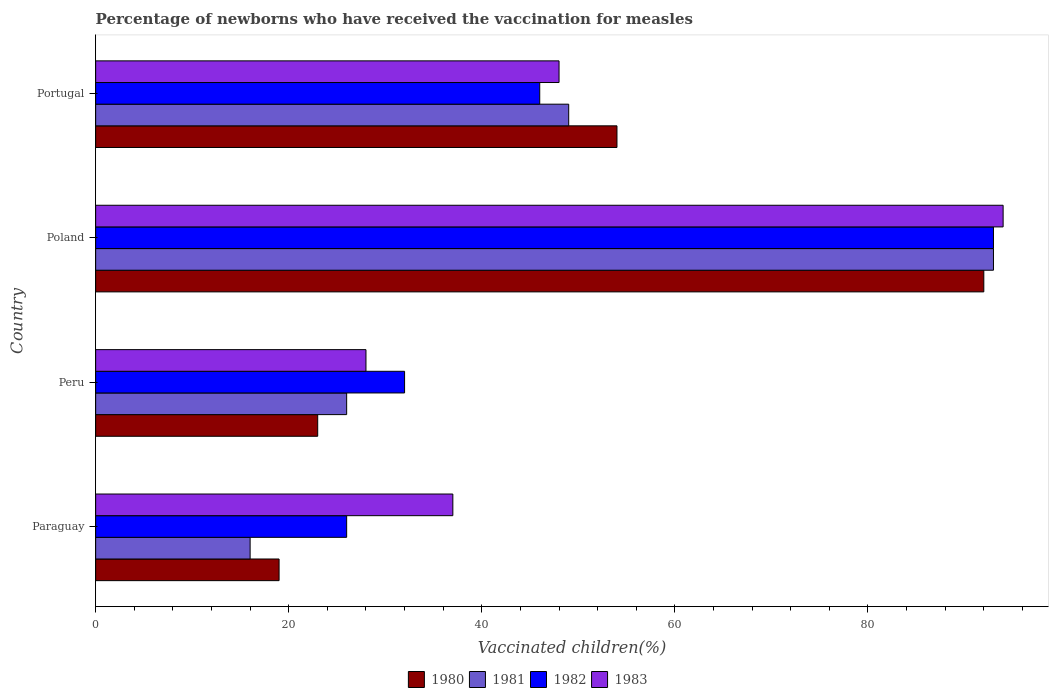How many different coloured bars are there?
Your answer should be compact. 4. Are the number of bars per tick equal to the number of legend labels?
Your answer should be very brief. Yes. How many bars are there on the 4th tick from the bottom?
Offer a terse response. 4. What is the label of the 1st group of bars from the top?
Give a very brief answer. Portugal. In how many cases, is the number of bars for a given country not equal to the number of legend labels?
Your answer should be compact. 0. What is the percentage of vaccinated children in 1980 in Portugal?
Your response must be concise. 54. Across all countries, what is the maximum percentage of vaccinated children in 1982?
Ensure brevity in your answer.  93. Across all countries, what is the minimum percentage of vaccinated children in 1982?
Provide a succinct answer. 26. In which country was the percentage of vaccinated children in 1980 minimum?
Give a very brief answer. Paraguay. What is the total percentage of vaccinated children in 1980 in the graph?
Provide a short and direct response. 188. What is the difference between the percentage of vaccinated children in 1983 in Peru and that in Poland?
Offer a terse response. -66. What is the difference between the percentage of vaccinated children in 1983 in Poland and the percentage of vaccinated children in 1982 in Paraguay?
Ensure brevity in your answer.  68. What is the average percentage of vaccinated children in 1982 per country?
Your answer should be very brief. 49.25. What is the difference between the percentage of vaccinated children in 1983 and percentage of vaccinated children in 1981 in Paraguay?
Keep it short and to the point. 21. In how many countries, is the percentage of vaccinated children in 1982 greater than 36 %?
Give a very brief answer. 2. What is the ratio of the percentage of vaccinated children in 1983 in Poland to that in Portugal?
Keep it short and to the point. 1.96. Is the percentage of vaccinated children in 1983 in Paraguay less than that in Portugal?
Make the answer very short. Yes. Is the difference between the percentage of vaccinated children in 1983 in Peru and Portugal greater than the difference between the percentage of vaccinated children in 1981 in Peru and Portugal?
Give a very brief answer. Yes. What is the difference between the highest and the lowest percentage of vaccinated children in 1980?
Your response must be concise. 73. Is the sum of the percentage of vaccinated children in 1980 in Poland and Portugal greater than the maximum percentage of vaccinated children in 1981 across all countries?
Give a very brief answer. Yes. Is it the case that in every country, the sum of the percentage of vaccinated children in 1983 and percentage of vaccinated children in 1980 is greater than the sum of percentage of vaccinated children in 1982 and percentage of vaccinated children in 1981?
Your answer should be compact. No. What is the difference between two consecutive major ticks on the X-axis?
Your answer should be compact. 20. Are the values on the major ticks of X-axis written in scientific E-notation?
Keep it short and to the point. No. How many legend labels are there?
Provide a short and direct response. 4. How are the legend labels stacked?
Keep it short and to the point. Horizontal. What is the title of the graph?
Offer a very short reply. Percentage of newborns who have received the vaccination for measles. What is the label or title of the X-axis?
Your response must be concise. Vaccinated children(%). What is the label or title of the Y-axis?
Give a very brief answer. Country. What is the Vaccinated children(%) of 1980 in Paraguay?
Provide a short and direct response. 19. What is the Vaccinated children(%) of 1981 in Paraguay?
Give a very brief answer. 16. What is the Vaccinated children(%) of 1982 in Paraguay?
Give a very brief answer. 26. What is the Vaccinated children(%) of 1983 in Paraguay?
Your response must be concise. 37. What is the Vaccinated children(%) of 1980 in Peru?
Make the answer very short. 23. What is the Vaccinated children(%) in 1981 in Peru?
Your answer should be compact. 26. What is the Vaccinated children(%) in 1982 in Peru?
Keep it short and to the point. 32. What is the Vaccinated children(%) of 1983 in Peru?
Offer a very short reply. 28. What is the Vaccinated children(%) in 1980 in Poland?
Keep it short and to the point. 92. What is the Vaccinated children(%) in 1981 in Poland?
Your answer should be very brief. 93. What is the Vaccinated children(%) of 1982 in Poland?
Offer a very short reply. 93. What is the Vaccinated children(%) of 1983 in Poland?
Offer a very short reply. 94. What is the Vaccinated children(%) in 1980 in Portugal?
Ensure brevity in your answer.  54. What is the Vaccinated children(%) in 1981 in Portugal?
Your answer should be very brief. 49. What is the Vaccinated children(%) in 1983 in Portugal?
Offer a terse response. 48. Across all countries, what is the maximum Vaccinated children(%) in 1980?
Give a very brief answer. 92. Across all countries, what is the maximum Vaccinated children(%) of 1981?
Provide a short and direct response. 93. Across all countries, what is the maximum Vaccinated children(%) of 1982?
Keep it short and to the point. 93. Across all countries, what is the maximum Vaccinated children(%) of 1983?
Your answer should be very brief. 94. What is the total Vaccinated children(%) in 1980 in the graph?
Give a very brief answer. 188. What is the total Vaccinated children(%) of 1981 in the graph?
Provide a succinct answer. 184. What is the total Vaccinated children(%) of 1982 in the graph?
Provide a succinct answer. 197. What is the total Vaccinated children(%) of 1983 in the graph?
Offer a terse response. 207. What is the difference between the Vaccinated children(%) of 1980 in Paraguay and that in Poland?
Your answer should be compact. -73. What is the difference between the Vaccinated children(%) in 1981 in Paraguay and that in Poland?
Give a very brief answer. -77. What is the difference between the Vaccinated children(%) in 1982 in Paraguay and that in Poland?
Ensure brevity in your answer.  -67. What is the difference between the Vaccinated children(%) in 1983 in Paraguay and that in Poland?
Offer a very short reply. -57. What is the difference between the Vaccinated children(%) of 1980 in Paraguay and that in Portugal?
Ensure brevity in your answer.  -35. What is the difference between the Vaccinated children(%) of 1981 in Paraguay and that in Portugal?
Make the answer very short. -33. What is the difference between the Vaccinated children(%) of 1982 in Paraguay and that in Portugal?
Give a very brief answer. -20. What is the difference between the Vaccinated children(%) in 1983 in Paraguay and that in Portugal?
Offer a very short reply. -11. What is the difference between the Vaccinated children(%) of 1980 in Peru and that in Poland?
Make the answer very short. -69. What is the difference between the Vaccinated children(%) in 1981 in Peru and that in Poland?
Keep it short and to the point. -67. What is the difference between the Vaccinated children(%) in 1982 in Peru and that in Poland?
Offer a very short reply. -61. What is the difference between the Vaccinated children(%) of 1983 in Peru and that in Poland?
Give a very brief answer. -66. What is the difference between the Vaccinated children(%) of 1980 in Peru and that in Portugal?
Make the answer very short. -31. What is the difference between the Vaccinated children(%) of 1981 in Peru and that in Portugal?
Your answer should be compact. -23. What is the difference between the Vaccinated children(%) of 1982 in Peru and that in Portugal?
Give a very brief answer. -14. What is the difference between the Vaccinated children(%) in 1983 in Peru and that in Portugal?
Keep it short and to the point. -20. What is the difference between the Vaccinated children(%) of 1980 in Poland and that in Portugal?
Ensure brevity in your answer.  38. What is the difference between the Vaccinated children(%) in 1981 in Poland and that in Portugal?
Provide a short and direct response. 44. What is the difference between the Vaccinated children(%) in 1980 in Paraguay and the Vaccinated children(%) in 1982 in Peru?
Give a very brief answer. -13. What is the difference between the Vaccinated children(%) of 1980 in Paraguay and the Vaccinated children(%) of 1981 in Poland?
Offer a very short reply. -74. What is the difference between the Vaccinated children(%) of 1980 in Paraguay and the Vaccinated children(%) of 1982 in Poland?
Your answer should be compact. -74. What is the difference between the Vaccinated children(%) in 1980 in Paraguay and the Vaccinated children(%) in 1983 in Poland?
Provide a short and direct response. -75. What is the difference between the Vaccinated children(%) of 1981 in Paraguay and the Vaccinated children(%) of 1982 in Poland?
Ensure brevity in your answer.  -77. What is the difference between the Vaccinated children(%) in 1981 in Paraguay and the Vaccinated children(%) in 1983 in Poland?
Offer a very short reply. -78. What is the difference between the Vaccinated children(%) in 1982 in Paraguay and the Vaccinated children(%) in 1983 in Poland?
Your answer should be very brief. -68. What is the difference between the Vaccinated children(%) of 1980 in Paraguay and the Vaccinated children(%) of 1981 in Portugal?
Give a very brief answer. -30. What is the difference between the Vaccinated children(%) in 1980 in Paraguay and the Vaccinated children(%) in 1982 in Portugal?
Your answer should be compact. -27. What is the difference between the Vaccinated children(%) of 1981 in Paraguay and the Vaccinated children(%) of 1982 in Portugal?
Your response must be concise. -30. What is the difference between the Vaccinated children(%) in 1981 in Paraguay and the Vaccinated children(%) in 1983 in Portugal?
Make the answer very short. -32. What is the difference between the Vaccinated children(%) in 1980 in Peru and the Vaccinated children(%) in 1981 in Poland?
Offer a terse response. -70. What is the difference between the Vaccinated children(%) of 1980 in Peru and the Vaccinated children(%) of 1982 in Poland?
Make the answer very short. -70. What is the difference between the Vaccinated children(%) in 1980 in Peru and the Vaccinated children(%) in 1983 in Poland?
Your response must be concise. -71. What is the difference between the Vaccinated children(%) in 1981 in Peru and the Vaccinated children(%) in 1982 in Poland?
Give a very brief answer. -67. What is the difference between the Vaccinated children(%) in 1981 in Peru and the Vaccinated children(%) in 1983 in Poland?
Offer a very short reply. -68. What is the difference between the Vaccinated children(%) of 1982 in Peru and the Vaccinated children(%) of 1983 in Poland?
Your answer should be very brief. -62. What is the difference between the Vaccinated children(%) in 1980 in Peru and the Vaccinated children(%) in 1983 in Portugal?
Offer a very short reply. -25. What is the difference between the Vaccinated children(%) of 1981 in Peru and the Vaccinated children(%) of 1983 in Portugal?
Ensure brevity in your answer.  -22. What is the difference between the Vaccinated children(%) in 1980 in Poland and the Vaccinated children(%) in 1983 in Portugal?
Make the answer very short. 44. What is the difference between the Vaccinated children(%) in 1982 in Poland and the Vaccinated children(%) in 1983 in Portugal?
Provide a short and direct response. 45. What is the average Vaccinated children(%) of 1980 per country?
Offer a terse response. 47. What is the average Vaccinated children(%) of 1981 per country?
Give a very brief answer. 46. What is the average Vaccinated children(%) of 1982 per country?
Provide a short and direct response. 49.25. What is the average Vaccinated children(%) in 1983 per country?
Keep it short and to the point. 51.75. What is the difference between the Vaccinated children(%) in 1981 and Vaccinated children(%) in 1983 in Paraguay?
Make the answer very short. -21. What is the difference between the Vaccinated children(%) in 1980 and Vaccinated children(%) in 1983 in Peru?
Offer a very short reply. -5. What is the difference between the Vaccinated children(%) of 1980 and Vaccinated children(%) of 1983 in Poland?
Provide a succinct answer. -2. What is the difference between the Vaccinated children(%) in 1981 and Vaccinated children(%) in 1982 in Poland?
Keep it short and to the point. 0. What is the difference between the Vaccinated children(%) of 1981 and Vaccinated children(%) of 1983 in Poland?
Make the answer very short. -1. What is the difference between the Vaccinated children(%) of 1980 and Vaccinated children(%) of 1981 in Portugal?
Make the answer very short. 5. What is the difference between the Vaccinated children(%) in 1980 and Vaccinated children(%) in 1983 in Portugal?
Offer a very short reply. 6. What is the ratio of the Vaccinated children(%) in 1980 in Paraguay to that in Peru?
Give a very brief answer. 0.83. What is the ratio of the Vaccinated children(%) of 1981 in Paraguay to that in Peru?
Ensure brevity in your answer.  0.62. What is the ratio of the Vaccinated children(%) of 1982 in Paraguay to that in Peru?
Offer a terse response. 0.81. What is the ratio of the Vaccinated children(%) of 1983 in Paraguay to that in Peru?
Give a very brief answer. 1.32. What is the ratio of the Vaccinated children(%) in 1980 in Paraguay to that in Poland?
Ensure brevity in your answer.  0.21. What is the ratio of the Vaccinated children(%) of 1981 in Paraguay to that in Poland?
Ensure brevity in your answer.  0.17. What is the ratio of the Vaccinated children(%) in 1982 in Paraguay to that in Poland?
Offer a terse response. 0.28. What is the ratio of the Vaccinated children(%) of 1983 in Paraguay to that in Poland?
Your answer should be very brief. 0.39. What is the ratio of the Vaccinated children(%) of 1980 in Paraguay to that in Portugal?
Your answer should be very brief. 0.35. What is the ratio of the Vaccinated children(%) in 1981 in Paraguay to that in Portugal?
Provide a short and direct response. 0.33. What is the ratio of the Vaccinated children(%) in 1982 in Paraguay to that in Portugal?
Your answer should be compact. 0.57. What is the ratio of the Vaccinated children(%) of 1983 in Paraguay to that in Portugal?
Provide a short and direct response. 0.77. What is the ratio of the Vaccinated children(%) of 1980 in Peru to that in Poland?
Provide a short and direct response. 0.25. What is the ratio of the Vaccinated children(%) in 1981 in Peru to that in Poland?
Offer a terse response. 0.28. What is the ratio of the Vaccinated children(%) of 1982 in Peru to that in Poland?
Your answer should be very brief. 0.34. What is the ratio of the Vaccinated children(%) of 1983 in Peru to that in Poland?
Provide a short and direct response. 0.3. What is the ratio of the Vaccinated children(%) of 1980 in Peru to that in Portugal?
Your answer should be very brief. 0.43. What is the ratio of the Vaccinated children(%) in 1981 in Peru to that in Portugal?
Ensure brevity in your answer.  0.53. What is the ratio of the Vaccinated children(%) in 1982 in Peru to that in Portugal?
Keep it short and to the point. 0.7. What is the ratio of the Vaccinated children(%) of 1983 in Peru to that in Portugal?
Your answer should be compact. 0.58. What is the ratio of the Vaccinated children(%) of 1980 in Poland to that in Portugal?
Provide a succinct answer. 1.7. What is the ratio of the Vaccinated children(%) of 1981 in Poland to that in Portugal?
Provide a succinct answer. 1.9. What is the ratio of the Vaccinated children(%) of 1982 in Poland to that in Portugal?
Ensure brevity in your answer.  2.02. What is the ratio of the Vaccinated children(%) in 1983 in Poland to that in Portugal?
Keep it short and to the point. 1.96. What is the difference between the highest and the second highest Vaccinated children(%) in 1980?
Your response must be concise. 38. What is the difference between the highest and the lowest Vaccinated children(%) of 1980?
Provide a succinct answer. 73. What is the difference between the highest and the lowest Vaccinated children(%) in 1981?
Ensure brevity in your answer.  77. What is the difference between the highest and the lowest Vaccinated children(%) of 1982?
Make the answer very short. 67. 